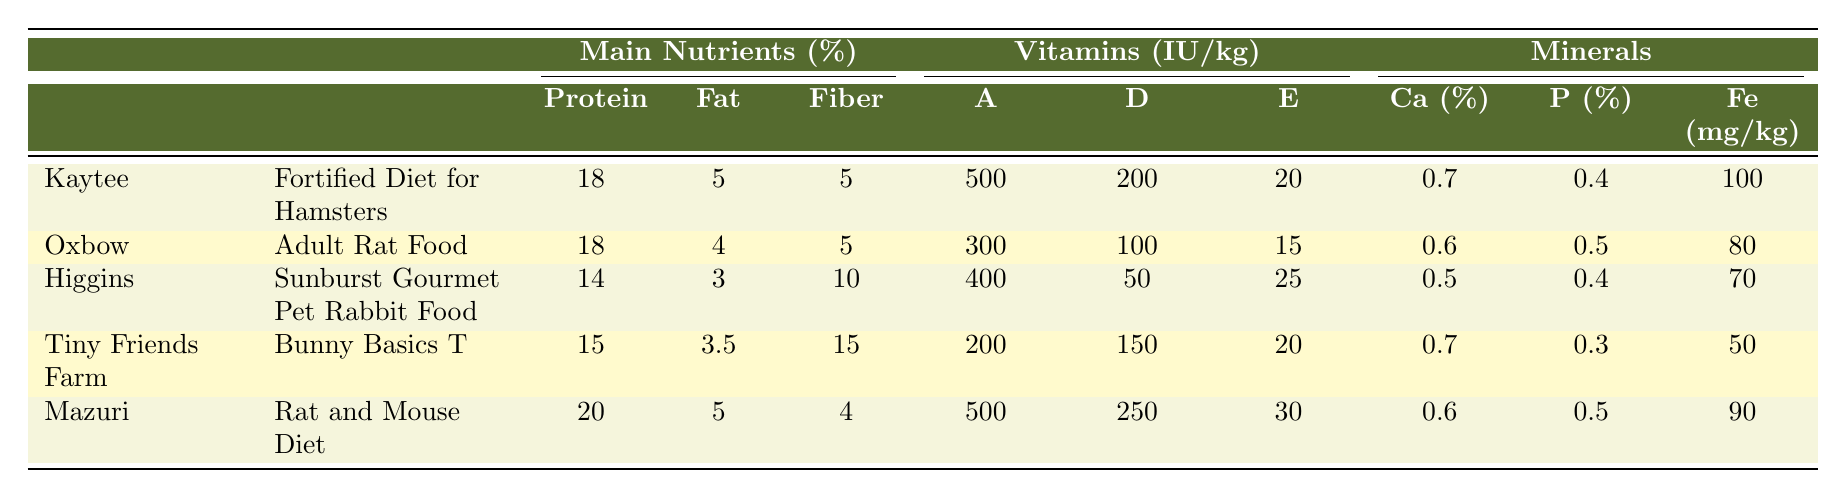What is the protein content of the Mazuri Rat and Mouse Diet? The protein content for the Mazuri product is listed under the 'Protein' column, which shows a value of 20%.
Answer: 20% Which product contains the highest fiber percentage? The fiber content is compared across the table, and Tiny Friends Farm's Bunny Basics T has the highest fiber percentage at 15%.
Answer: 15% Is the calcium content in Oxbow's Adult Rat Food higher than that in Kaytee's Fortified Diet for Hamsters? Oxbow's calcium content is 0.6%, whereas Kaytee's calcium content is 0.7%, so Oxbow's is lower.
Answer: No What is the average fat percentage of all the products listed? The fat percentages are 5%, 4%, 3%, 3.5%, and 5%. Adding them gives 20.5%, and dividing by 5 yields an average of 4.1%.
Answer: 4.1% Which brand has the highest amount of Vitamin D per kilogram? Comparing the Vitamin D values, Mazuri has 250 IU/kg, which is higher than all other products listed.
Answer: Mazuri What mineral has the lowest value among the products? Examining the minerals, Tiny Friends Farm's Bunny Basics T has the lowest iron content at 50 mg/kg.
Answer: Iron What is the combined protein content of Kaytee's and Higgins' products? Kaytee's protein is 18% and Higgins' is 14%. Adding those together gives a total protein content of 32%.
Answer: 32% Is there a product that has both the highest fiber content and the highest Vitamin E content? No single product holds both titles; Tiny Friends Farm has the highest fiber (15%), while Mazuri has the highest Vitamin E (30 IU/kg).
Answer: No Calculate the difference in iron content between Oxbow's and Mazuri's products. Oxbow's iron content is 80 mg/kg and Mazuri's is 90 mg/kg. The difference is 90 - 80 = 10 mg/kg.
Answer: 10 mg/kg Which product is the most fortified in terms of vitamins? Evaluating the vitamins, Mazuri has the highest values for both Vitamin A (500 IU/kg) and Vitamin D (250 IU/kg), making it the most fortified.
Answer: Mazuri 